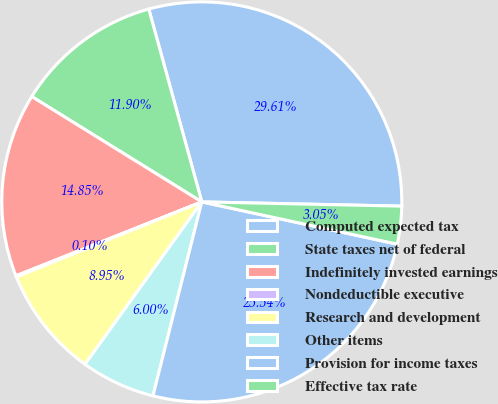Convert chart to OTSL. <chart><loc_0><loc_0><loc_500><loc_500><pie_chart><fcel>Computed expected tax<fcel>State taxes net of federal<fcel>Indefinitely invested earnings<fcel>Nondeductible executive<fcel>Research and development<fcel>Other items<fcel>Provision for income taxes<fcel>Effective tax rate<nl><fcel>29.6%<fcel>11.9%<fcel>14.85%<fcel>0.1%<fcel>8.95%<fcel>6.0%<fcel>25.53%<fcel>3.05%<nl></chart> 